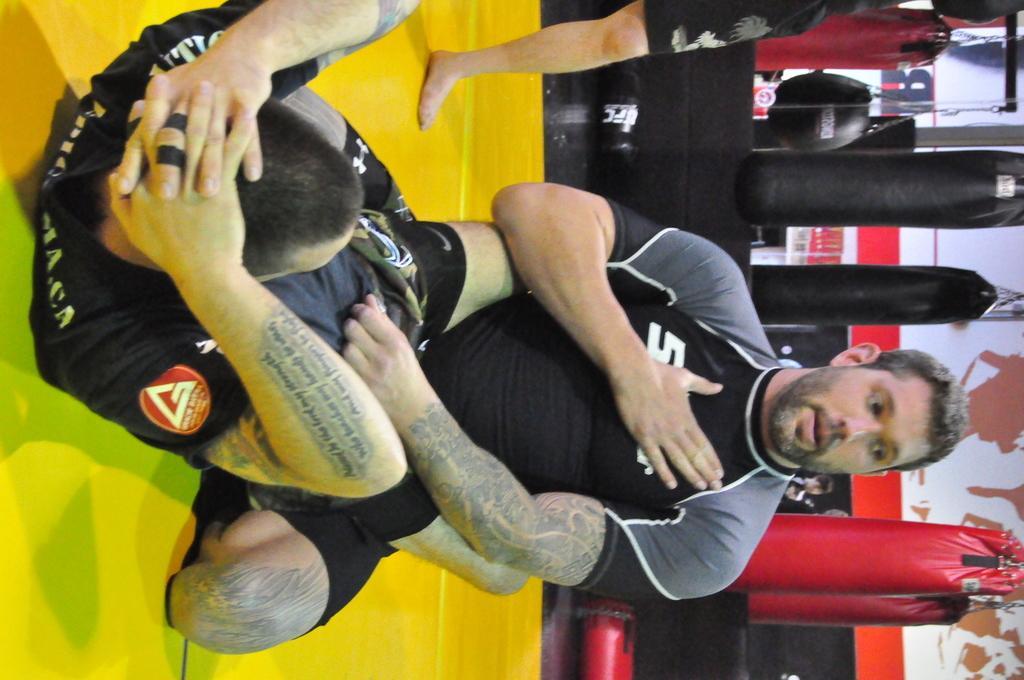Please provide a concise description of this image. This image is right direction. In the middle of this image there is a man wearing a t-shirt and sitting on the knees. In front of him there is another man laying on the floor and doing some exercise. At the top of the image there is a person standing. In the background there is some equipment which is used to exercise and there is a wall. 